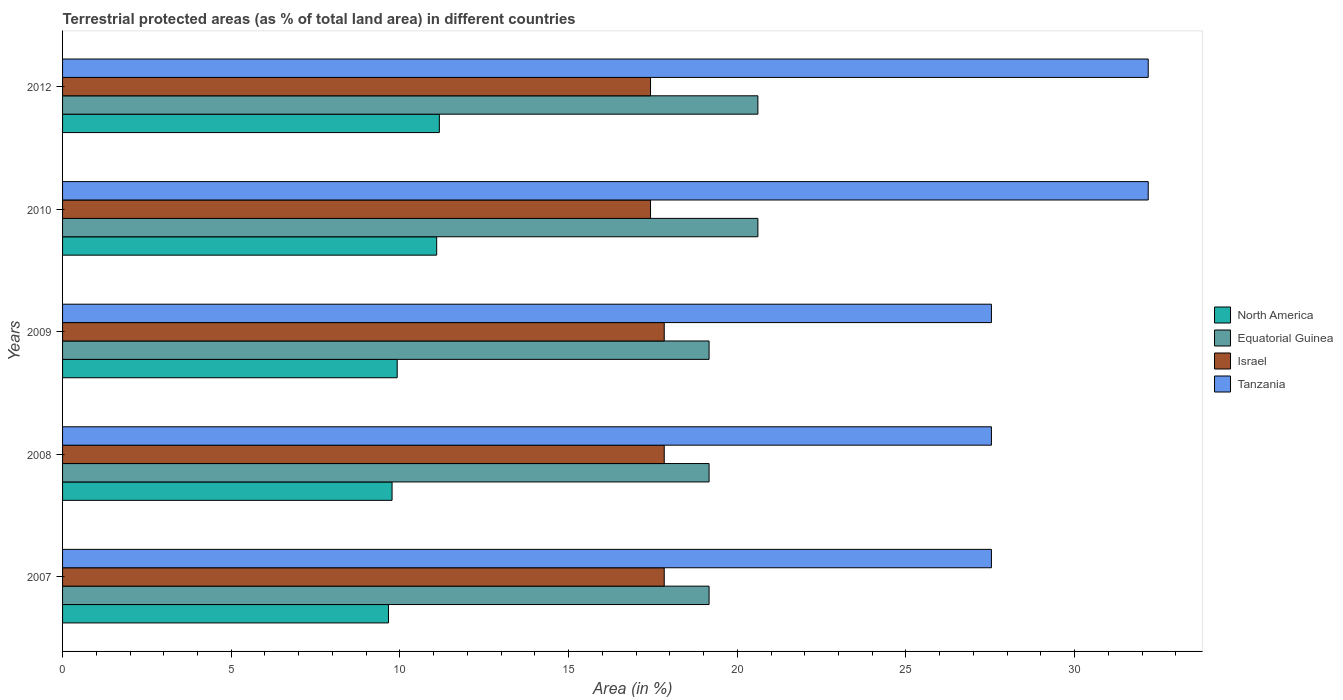How many groups of bars are there?
Offer a very short reply. 5. Are the number of bars per tick equal to the number of legend labels?
Your response must be concise. Yes. Are the number of bars on each tick of the Y-axis equal?
Provide a succinct answer. Yes. How many bars are there on the 1st tick from the bottom?
Make the answer very short. 4. What is the label of the 4th group of bars from the top?
Keep it short and to the point. 2008. In how many cases, is the number of bars for a given year not equal to the number of legend labels?
Offer a very short reply. 0. What is the percentage of terrestrial protected land in North America in 2012?
Your response must be concise. 11.17. Across all years, what is the maximum percentage of terrestrial protected land in Equatorial Guinea?
Provide a succinct answer. 20.61. Across all years, what is the minimum percentage of terrestrial protected land in Tanzania?
Your response must be concise. 27.53. What is the total percentage of terrestrial protected land in Israel in the graph?
Make the answer very short. 88.36. What is the difference between the percentage of terrestrial protected land in Equatorial Guinea in 2007 and the percentage of terrestrial protected land in North America in 2012?
Give a very brief answer. 8. What is the average percentage of terrestrial protected land in North America per year?
Ensure brevity in your answer.  10.32. In the year 2008, what is the difference between the percentage of terrestrial protected land in North America and percentage of terrestrial protected land in Equatorial Guinea?
Offer a terse response. -9.4. What is the ratio of the percentage of terrestrial protected land in Israel in 2010 to that in 2012?
Offer a very short reply. 1. Is the percentage of terrestrial protected land in North America in 2007 less than that in 2009?
Offer a terse response. Yes. Is the difference between the percentage of terrestrial protected land in North America in 2007 and 2008 greater than the difference between the percentage of terrestrial protected land in Equatorial Guinea in 2007 and 2008?
Your answer should be compact. No. What is the difference between the highest and the second highest percentage of terrestrial protected land in North America?
Give a very brief answer. 0.08. What is the difference between the highest and the lowest percentage of terrestrial protected land in Equatorial Guinea?
Provide a succinct answer. 1.45. What does the 3rd bar from the top in 2009 represents?
Offer a very short reply. Equatorial Guinea. What does the 4th bar from the bottom in 2010 represents?
Keep it short and to the point. Tanzania. Is it the case that in every year, the sum of the percentage of terrestrial protected land in Equatorial Guinea and percentage of terrestrial protected land in Tanzania is greater than the percentage of terrestrial protected land in Israel?
Ensure brevity in your answer.  Yes. How many years are there in the graph?
Your answer should be very brief. 5. What is the difference between two consecutive major ticks on the X-axis?
Ensure brevity in your answer.  5. Does the graph contain any zero values?
Your answer should be very brief. No. Does the graph contain grids?
Provide a succinct answer. No. Where does the legend appear in the graph?
Your answer should be compact. Center right. How many legend labels are there?
Make the answer very short. 4. What is the title of the graph?
Make the answer very short. Terrestrial protected areas (as % of total land area) in different countries. Does "Madagascar" appear as one of the legend labels in the graph?
Keep it short and to the point. No. What is the label or title of the X-axis?
Offer a very short reply. Area (in %). What is the Area (in %) of North America in 2007?
Provide a short and direct response. 9.66. What is the Area (in %) of Equatorial Guinea in 2007?
Provide a short and direct response. 19.16. What is the Area (in %) of Israel in 2007?
Ensure brevity in your answer.  17.83. What is the Area (in %) of Tanzania in 2007?
Provide a succinct answer. 27.53. What is the Area (in %) of North America in 2008?
Provide a short and direct response. 9.77. What is the Area (in %) in Equatorial Guinea in 2008?
Offer a terse response. 19.16. What is the Area (in %) of Israel in 2008?
Keep it short and to the point. 17.83. What is the Area (in %) of Tanzania in 2008?
Offer a very short reply. 27.53. What is the Area (in %) of North America in 2009?
Make the answer very short. 9.92. What is the Area (in %) in Equatorial Guinea in 2009?
Keep it short and to the point. 19.16. What is the Area (in %) in Israel in 2009?
Make the answer very short. 17.83. What is the Area (in %) in Tanzania in 2009?
Make the answer very short. 27.53. What is the Area (in %) of North America in 2010?
Keep it short and to the point. 11.09. What is the Area (in %) in Equatorial Guinea in 2010?
Provide a short and direct response. 20.61. What is the Area (in %) of Israel in 2010?
Keep it short and to the point. 17.43. What is the Area (in %) of Tanzania in 2010?
Offer a terse response. 32.18. What is the Area (in %) in North America in 2012?
Offer a very short reply. 11.17. What is the Area (in %) of Equatorial Guinea in 2012?
Your response must be concise. 20.61. What is the Area (in %) of Israel in 2012?
Make the answer very short. 17.43. What is the Area (in %) of Tanzania in 2012?
Make the answer very short. 32.18. Across all years, what is the maximum Area (in %) of North America?
Give a very brief answer. 11.17. Across all years, what is the maximum Area (in %) in Equatorial Guinea?
Your response must be concise. 20.61. Across all years, what is the maximum Area (in %) in Israel?
Offer a terse response. 17.83. Across all years, what is the maximum Area (in %) of Tanzania?
Make the answer very short. 32.18. Across all years, what is the minimum Area (in %) in North America?
Keep it short and to the point. 9.66. Across all years, what is the minimum Area (in %) of Equatorial Guinea?
Keep it short and to the point. 19.16. Across all years, what is the minimum Area (in %) in Israel?
Your answer should be compact. 17.43. Across all years, what is the minimum Area (in %) in Tanzania?
Provide a succinct answer. 27.53. What is the total Area (in %) in North America in the graph?
Keep it short and to the point. 51.6. What is the total Area (in %) in Equatorial Guinea in the graph?
Your answer should be very brief. 98.71. What is the total Area (in %) of Israel in the graph?
Give a very brief answer. 88.36. What is the total Area (in %) in Tanzania in the graph?
Keep it short and to the point. 146.96. What is the difference between the Area (in %) of North America in 2007 and that in 2008?
Give a very brief answer. -0.11. What is the difference between the Area (in %) of Equatorial Guinea in 2007 and that in 2008?
Keep it short and to the point. 0. What is the difference between the Area (in %) of Israel in 2007 and that in 2008?
Make the answer very short. 0. What is the difference between the Area (in %) of Tanzania in 2007 and that in 2008?
Give a very brief answer. 0. What is the difference between the Area (in %) in North America in 2007 and that in 2009?
Offer a very short reply. -0.26. What is the difference between the Area (in %) of Tanzania in 2007 and that in 2009?
Your answer should be compact. 0. What is the difference between the Area (in %) of North America in 2007 and that in 2010?
Keep it short and to the point. -1.43. What is the difference between the Area (in %) of Equatorial Guinea in 2007 and that in 2010?
Offer a very short reply. -1.45. What is the difference between the Area (in %) in Israel in 2007 and that in 2010?
Offer a terse response. 0.41. What is the difference between the Area (in %) of Tanzania in 2007 and that in 2010?
Your answer should be compact. -4.65. What is the difference between the Area (in %) of North America in 2007 and that in 2012?
Make the answer very short. -1.51. What is the difference between the Area (in %) in Equatorial Guinea in 2007 and that in 2012?
Ensure brevity in your answer.  -1.45. What is the difference between the Area (in %) of Israel in 2007 and that in 2012?
Make the answer very short. 0.41. What is the difference between the Area (in %) in Tanzania in 2007 and that in 2012?
Provide a succinct answer. -4.65. What is the difference between the Area (in %) of North America in 2008 and that in 2009?
Offer a very short reply. -0.15. What is the difference between the Area (in %) of Israel in 2008 and that in 2009?
Ensure brevity in your answer.  0. What is the difference between the Area (in %) of North America in 2008 and that in 2010?
Your response must be concise. -1.32. What is the difference between the Area (in %) in Equatorial Guinea in 2008 and that in 2010?
Your answer should be very brief. -1.45. What is the difference between the Area (in %) in Israel in 2008 and that in 2010?
Your answer should be very brief. 0.41. What is the difference between the Area (in %) of Tanzania in 2008 and that in 2010?
Give a very brief answer. -4.65. What is the difference between the Area (in %) of North America in 2008 and that in 2012?
Provide a succinct answer. -1.4. What is the difference between the Area (in %) of Equatorial Guinea in 2008 and that in 2012?
Provide a short and direct response. -1.45. What is the difference between the Area (in %) of Israel in 2008 and that in 2012?
Offer a very short reply. 0.41. What is the difference between the Area (in %) of Tanzania in 2008 and that in 2012?
Provide a short and direct response. -4.65. What is the difference between the Area (in %) of North America in 2009 and that in 2010?
Your response must be concise. -1.17. What is the difference between the Area (in %) in Equatorial Guinea in 2009 and that in 2010?
Provide a short and direct response. -1.45. What is the difference between the Area (in %) of Israel in 2009 and that in 2010?
Give a very brief answer. 0.41. What is the difference between the Area (in %) in Tanzania in 2009 and that in 2010?
Offer a very short reply. -4.65. What is the difference between the Area (in %) in North America in 2009 and that in 2012?
Make the answer very short. -1.25. What is the difference between the Area (in %) of Equatorial Guinea in 2009 and that in 2012?
Your response must be concise. -1.45. What is the difference between the Area (in %) of Israel in 2009 and that in 2012?
Your answer should be very brief. 0.41. What is the difference between the Area (in %) of Tanzania in 2009 and that in 2012?
Ensure brevity in your answer.  -4.65. What is the difference between the Area (in %) of North America in 2010 and that in 2012?
Give a very brief answer. -0.08. What is the difference between the Area (in %) in Tanzania in 2010 and that in 2012?
Your response must be concise. 0. What is the difference between the Area (in %) of North America in 2007 and the Area (in %) of Equatorial Guinea in 2008?
Offer a very short reply. -9.5. What is the difference between the Area (in %) of North America in 2007 and the Area (in %) of Israel in 2008?
Provide a succinct answer. -8.17. What is the difference between the Area (in %) of North America in 2007 and the Area (in %) of Tanzania in 2008?
Provide a succinct answer. -17.87. What is the difference between the Area (in %) in Equatorial Guinea in 2007 and the Area (in %) in Israel in 2008?
Your answer should be very brief. 1.33. What is the difference between the Area (in %) of Equatorial Guinea in 2007 and the Area (in %) of Tanzania in 2008?
Keep it short and to the point. -8.37. What is the difference between the Area (in %) in Israel in 2007 and the Area (in %) in Tanzania in 2008?
Provide a succinct answer. -9.7. What is the difference between the Area (in %) of North America in 2007 and the Area (in %) of Equatorial Guinea in 2009?
Your answer should be very brief. -9.5. What is the difference between the Area (in %) in North America in 2007 and the Area (in %) in Israel in 2009?
Offer a very short reply. -8.17. What is the difference between the Area (in %) in North America in 2007 and the Area (in %) in Tanzania in 2009?
Give a very brief answer. -17.87. What is the difference between the Area (in %) of Equatorial Guinea in 2007 and the Area (in %) of Israel in 2009?
Keep it short and to the point. 1.33. What is the difference between the Area (in %) in Equatorial Guinea in 2007 and the Area (in %) in Tanzania in 2009?
Your answer should be very brief. -8.37. What is the difference between the Area (in %) of Israel in 2007 and the Area (in %) of Tanzania in 2009?
Offer a very short reply. -9.7. What is the difference between the Area (in %) in North America in 2007 and the Area (in %) in Equatorial Guinea in 2010?
Offer a terse response. -10.95. What is the difference between the Area (in %) of North America in 2007 and the Area (in %) of Israel in 2010?
Provide a short and direct response. -7.77. What is the difference between the Area (in %) in North America in 2007 and the Area (in %) in Tanzania in 2010?
Give a very brief answer. -22.52. What is the difference between the Area (in %) of Equatorial Guinea in 2007 and the Area (in %) of Israel in 2010?
Your response must be concise. 1.74. What is the difference between the Area (in %) in Equatorial Guinea in 2007 and the Area (in %) in Tanzania in 2010?
Provide a succinct answer. -13.02. What is the difference between the Area (in %) of Israel in 2007 and the Area (in %) of Tanzania in 2010?
Your answer should be compact. -14.35. What is the difference between the Area (in %) of North America in 2007 and the Area (in %) of Equatorial Guinea in 2012?
Give a very brief answer. -10.95. What is the difference between the Area (in %) of North America in 2007 and the Area (in %) of Israel in 2012?
Your answer should be compact. -7.77. What is the difference between the Area (in %) in North America in 2007 and the Area (in %) in Tanzania in 2012?
Your response must be concise. -22.52. What is the difference between the Area (in %) of Equatorial Guinea in 2007 and the Area (in %) of Israel in 2012?
Offer a terse response. 1.74. What is the difference between the Area (in %) in Equatorial Guinea in 2007 and the Area (in %) in Tanzania in 2012?
Your answer should be compact. -13.02. What is the difference between the Area (in %) in Israel in 2007 and the Area (in %) in Tanzania in 2012?
Offer a very short reply. -14.35. What is the difference between the Area (in %) of North America in 2008 and the Area (in %) of Equatorial Guinea in 2009?
Provide a short and direct response. -9.4. What is the difference between the Area (in %) in North America in 2008 and the Area (in %) in Israel in 2009?
Offer a terse response. -8.07. What is the difference between the Area (in %) in North America in 2008 and the Area (in %) in Tanzania in 2009?
Provide a short and direct response. -17.77. What is the difference between the Area (in %) of Equatorial Guinea in 2008 and the Area (in %) of Israel in 2009?
Offer a very short reply. 1.33. What is the difference between the Area (in %) of Equatorial Guinea in 2008 and the Area (in %) of Tanzania in 2009?
Provide a succinct answer. -8.37. What is the difference between the Area (in %) in Israel in 2008 and the Area (in %) in Tanzania in 2009?
Give a very brief answer. -9.7. What is the difference between the Area (in %) in North America in 2008 and the Area (in %) in Equatorial Guinea in 2010?
Ensure brevity in your answer.  -10.84. What is the difference between the Area (in %) in North America in 2008 and the Area (in %) in Israel in 2010?
Offer a very short reply. -7.66. What is the difference between the Area (in %) of North America in 2008 and the Area (in %) of Tanzania in 2010?
Offer a very short reply. -22.41. What is the difference between the Area (in %) in Equatorial Guinea in 2008 and the Area (in %) in Israel in 2010?
Ensure brevity in your answer.  1.74. What is the difference between the Area (in %) of Equatorial Guinea in 2008 and the Area (in %) of Tanzania in 2010?
Keep it short and to the point. -13.02. What is the difference between the Area (in %) of Israel in 2008 and the Area (in %) of Tanzania in 2010?
Your answer should be compact. -14.35. What is the difference between the Area (in %) in North America in 2008 and the Area (in %) in Equatorial Guinea in 2012?
Give a very brief answer. -10.84. What is the difference between the Area (in %) in North America in 2008 and the Area (in %) in Israel in 2012?
Your answer should be very brief. -7.66. What is the difference between the Area (in %) of North America in 2008 and the Area (in %) of Tanzania in 2012?
Offer a very short reply. -22.41. What is the difference between the Area (in %) in Equatorial Guinea in 2008 and the Area (in %) in Israel in 2012?
Your answer should be very brief. 1.74. What is the difference between the Area (in %) in Equatorial Guinea in 2008 and the Area (in %) in Tanzania in 2012?
Your response must be concise. -13.02. What is the difference between the Area (in %) of Israel in 2008 and the Area (in %) of Tanzania in 2012?
Provide a short and direct response. -14.35. What is the difference between the Area (in %) in North America in 2009 and the Area (in %) in Equatorial Guinea in 2010?
Keep it short and to the point. -10.69. What is the difference between the Area (in %) in North America in 2009 and the Area (in %) in Israel in 2010?
Your response must be concise. -7.51. What is the difference between the Area (in %) in North America in 2009 and the Area (in %) in Tanzania in 2010?
Offer a very short reply. -22.26. What is the difference between the Area (in %) of Equatorial Guinea in 2009 and the Area (in %) of Israel in 2010?
Offer a terse response. 1.74. What is the difference between the Area (in %) in Equatorial Guinea in 2009 and the Area (in %) in Tanzania in 2010?
Keep it short and to the point. -13.02. What is the difference between the Area (in %) of Israel in 2009 and the Area (in %) of Tanzania in 2010?
Ensure brevity in your answer.  -14.35. What is the difference between the Area (in %) in North America in 2009 and the Area (in %) in Equatorial Guinea in 2012?
Make the answer very short. -10.69. What is the difference between the Area (in %) of North America in 2009 and the Area (in %) of Israel in 2012?
Your response must be concise. -7.51. What is the difference between the Area (in %) in North America in 2009 and the Area (in %) in Tanzania in 2012?
Your answer should be compact. -22.26. What is the difference between the Area (in %) of Equatorial Guinea in 2009 and the Area (in %) of Israel in 2012?
Your response must be concise. 1.74. What is the difference between the Area (in %) of Equatorial Guinea in 2009 and the Area (in %) of Tanzania in 2012?
Ensure brevity in your answer.  -13.02. What is the difference between the Area (in %) of Israel in 2009 and the Area (in %) of Tanzania in 2012?
Provide a succinct answer. -14.35. What is the difference between the Area (in %) of North America in 2010 and the Area (in %) of Equatorial Guinea in 2012?
Your response must be concise. -9.52. What is the difference between the Area (in %) of North America in 2010 and the Area (in %) of Israel in 2012?
Ensure brevity in your answer.  -6.34. What is the difference between the Area (in %) of North America in 2010 and the Area (in %) of Tanzania in 2012?
Your answer should be compact. -21.09. What is the difference between the Area (in %) in Equatorial Guinea in 2010 and the Area (in %) in Israel in 2012?
Your answer should be compact. 3.18. What is the difference between the Area (in %) in Equatorial Guinea in 2010 and the Area (in %) in Tanzania in 2012?
Ensure brevity in your answer.  -11.57. What is the difference between the Area (in %) of Israel in 2010 and the Area (in %) of Tanzania in 2012?
Make the answer very short. -14.75. What is the average Area (in %) of North America per year?
Your response must be concise. 10.32. What is the average Area (in %) of Equatorial Guinea per year?
Give a very brief answer. 19.74. What is the average Area (in %) of Israel per year?
Give a very brief answer. 17.67. What is the average Area (in %) in Tanzania per year?
Give a very brief answer. 29.39. In the year 2007, what is the difference between the Area (in %) in North America and Area (in %) in Equatorial Guinea?
Your answer should be compact. -9.5. In the year 2007, what is the difference between the Area (in %) of North America and Area (in %) of Israel?
Provide a short and direct response. -8.17. In the year 2007, what is the difference between the Area (in %) in North America and Area (in %) in Tanzania?
Ensure brevity in your answer.  -17.87. In the year 2007, what is the difference between the Area (in %) of Equatorial Guinea and Area (in %) of Israel?
Your answer should be very brief. 1.33. In the year 2007, what is the difference between the Area (in %) of Equatorial Guinea and Area (in %) of Tanzania?
Offer a very short reply. -8.37. In the year 2007, what is the difference between the Area (in %) of Israel and Area (in %) of Tanzania?
Your answer should be very brief. -9.7. In the year 2008, what is the difference between the Area (in %) in North America and Area (in %) in Equatorial Guinea?
Your answer should be compact. -9.4. In the year 2008, what is the difference between the Area (in %) in North America and Area (in %) in Israel?
Provide a short and direct response. -8.07. In the year 2008, what is the difference between the Area (in %) of North America and Area (in %) of Tanzania?
Keep it short and to the point. -17.77. In the year 2008, what is the difference between the Area (in %) in Equatorial Guinea and Area (in %) in Israel?
Ensure brevity in your answer.  1.33. In the year 2008, what is the difference between the Area (in %) in Equatorial Guinea and Area (in %) in Tanzania?
Make the answer very short. -8.37. In the year 2008, what is the difference between the Area (in %) in Israel and Area (in %) in Tanzania?
Make the answer very short. -9.7. In the year 2009, what is the difference between the Area (in %) of North America and Area (in %) of Equatorial Guinea?
Provide a succinct answer. -9.24. In the year 2009, what is the difference between the Area (in %) of North America and Area (in %) of Israel?
Make the answer very short. -7.92. In the year 2009, what is the difference between the Area (in %) of North America and Area (in %) of Tanzania?
Offer a terse response. -17.61. In the year 2009, what is the difference between the Area (in %) in Equatorial Guinea and Area (in %) in Israel?
Offer a terse response. 1.33. In the year 2009, what is the difference between the Area (in %) of Equatorial Guinea and Area (in %) of Tanzania?
Offer a terse response. -8.37. In the year 2009, what is the difference between the Area (in %) in Israel and Area (in %) in Tanzania?
Offer a very short reply. -9.7. In the year 2010, what is the difference between the Area (in %) of North America and Area (in %) of Equatorial Guinea?
Keep it short and to the point. -9.52. In the year 2010, what is the difference between the Area (in %) in North America and Area (in %) in Israel?
Keep it short and to the point. -6.34. In the year 2010, what is the difference between the Area (in %) of North America and Area (in %) of Tanzania?
Provide a succinct answer. -21.09. In the year 2010, what is the difference between the Area (in %) in Equatorial Guinea and Area (in %) in Israel?
Your answer should be compact. 3.18. In the year 2010, what is the difference between the Area (in %) of Equatorial Guinea and Area (in %) of Tanzania?
Make the answer very short. -11.57. In the year 2010, what is the difference between the Area (in %) in Israel and Area (in %) in Tanzania?
Ensure brevity in your answer.  -14.75. In the year 2012, what is the difference between the Area (in %) in North America and Area (in %) in Equatorial Guinea?
Your answer should be very brief. -9.44. In the year 2012, what is the difference between the Area (in %) of North America and Area (in %) of Israel?
Ensure brevity in your answer.  -6.26. In the year 2012, what is the difference between the Area (in %) of North America and Area (in %) of Tanzania?
Make the answer very short. -21.01. In the year 2012, what is the difference between the Area (in %) in Equatorial Guinea and Area (in %) in Israel?
Provide a short and direct response. 3.18. In the year 2012, what is the difference between the Area (in %) in Equatorial Guinea and Area (in %) in Tanzania?
Offer a terse response. -11.57. In the year 2012, what is the difference between the Area (in %) in Israel and Area (in %) in Tanzania?
Your response must be concise. -14.75. What is the ratio of the Area (in %) of North America in 2007 to that in 2008?
Your answer should be compact. 0.99. What is the ratio of the Area (in %) of Israel in 2007 to that in 2008?
Your answer should be compact. 1. What is the ratio of the Area (in %) of Tanzania in 2007 to that in 2008?
Your answer should be very brief. 1. What is the ratio of the Area (in %) of North America in 2007 to that in 2009?
Provide a short and direct response. 0.97. What is the ratio of the Area (in %) of Tanzania in 2007 to that in 2009?
Give a very brief answer. 1. What is the ratio of the Area (in %) in North America in 2007 to that in 2010?
Keep it short and to the point. 0.87. What is the ratio of the Area (in %) of Equatorial Guinea in 2007 to that in 2010?
Offer a very short reply. 0.93. What is the ratio of the Area (in %) in Israel in 2007 to that in 2010?
Your answer should be very brief. 1.02. What is the ratio of the Area (in %) of Tanzania in 2007 to that in 2010?
Provide a succinct answer. 0.86. What is the ratio of the Area (in %) of North America in 2007 to that in 2012?
Give a very brief answer. 0.86. What is the ratio of the Area (in %) in Equatorial Guinea in 2007 to that in 2012?
Your answer should be compact. 0.93. What is the ratio of the Area (in %) of Israel in 2007 to that in 2012?
Your answer should be compact. 1.02. What is the ratio of the Area (in %) in Tanzania in 2007 to that in 2012?
Give a very brief answer. 0.86. What is the ratio of the Area (in %) of North America in 2008 to that in 2009?
Ensure brevity in your answer.  0.98. What is the ratio of the Area (in %) of Equatorial Guinea in 2008 to that in 2009?
Your answer should be very brief. 1. What is the ratio of the Area (in %) of Tanzania in 2008 to that in 2009?
Your answer should be very brief. 1. What is the ratio of the Area (in %) of North America in 2008 to that in 2010?
Make the answer very short. 0.88. What is the ratio of the Area (in %) in Equatorial Guinea in 2008 to that in 2010?
Provide a succinct answer. 0.93. What is the ratio of the Area (in %) of Israel in 2008 to that in 2010?
Your response must be concise. 1.02. What is the ratio of the Area (in %) of Tanzania in 2008 to that in 2010?
Make the answer very short. 0.86. What is the ratio of the Area (in %) of North America in 2008 to that in 2012?
Your response must be concise. 0.87. What is the ratio of the Area (in %) in Equatorial Guinea in 2008 to that in 2012?
Offer a terse response. 0.93. What is the ratio of the Area (in %) in Israel in 2008 to that in 2012?
Provide a succinct answer. 1.02. What is the ratio of the Area (in %) in Tanzania in 2008 to that in 2012?
Give a very brief answer. 0.86. What is the ratio of the Area (in %) of North America in 2009 to that in 2010?
Make the answer very short. 0.89. What is the ratio of the Area (in %) in Equatorial Guinea in 2009 to that in 2010?
Provide a short and direct response. 0.93. What is the ratio of the Area (in %) of Israel in 2009 to that in 2010?
Offer a very short reply. 1.02. What is the ratio of the Area (in %) of Tanzania in 2009 to that in 2010?
Offer a terse response. 0.86. What is the ratio of the Area (in %) of North America in 2009 to that in 2012?
Provide a short and direct response. 0.89. What is the ratio of the Area (in %) of Equatorial Guinea in 2009 to that in 2012?
Ensure brevity in your answer.  0.93. What is the ratio of the Area (in %) of Israel in 2009 to that in 2012?
Offer a terse response. 1.02. What is the ratio of the Area (in %) in Tanzania in 2009 to that in 2012?
Your response must be concise. 0.86. What is the ratio of the Area (in %) of North America in 2010 to that in 2012?
Offer a terse response. 0.99. What is the ratio of the Area (in %) in Equatorial Guinea in 2010 to that in 2012?
Provide a succinct answer. 1. What is the difference between the highest and the second highest Area (in %) of North America?
Offer a very short reply. 0.08. What is the difference between the highest and the second highest Area (in %) of Israel?
Provide a succinct answer. 0. What is the difference between the highest and the second highest Area (in %) in Tanzania?
Your answer should be very brief. 0. What is the difference between the highest and the lowest Area (in %) of North America?
Your answer should be compact. 1.51. What is the difference between the highest and the lowest Area (in %) in Equatorial Guinea?
Provide a succinct answer. 1.45. What is the difference between the highest and the lowest Area (in %) of Israel?
Provide a succinct answer. 0.41. What is the difference between the highest and the lowest Area (in %) in Tanzania?
Provide a succinct answer. 4.65. 